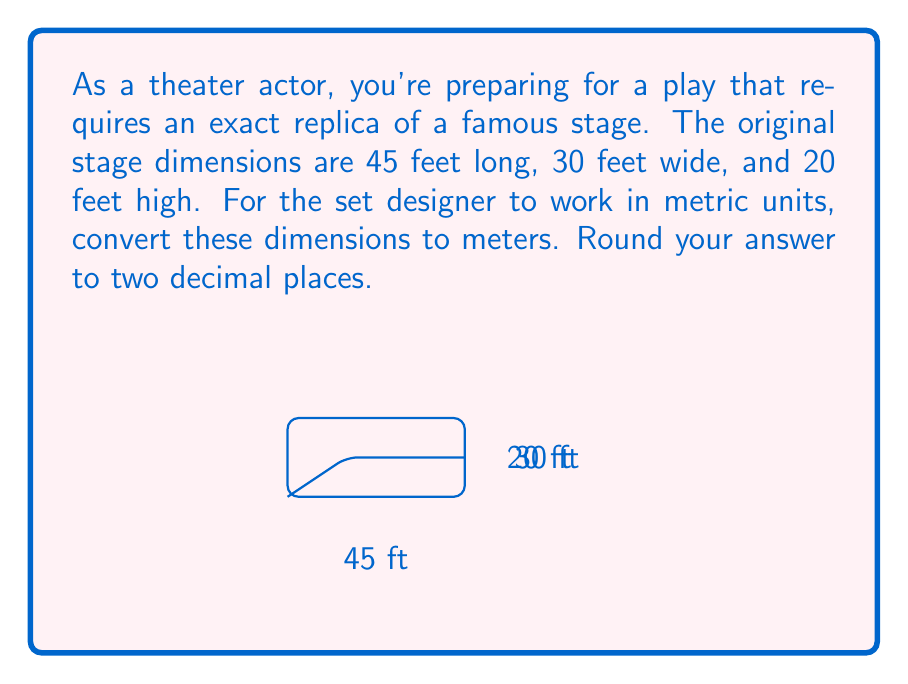Can you solve this math problem? To convert from feet to meters, we need to use the conversion factor:
1 foot = 0.3048 meters

Let's convert each dimension:

1. Length: 45 feet
   $45 \times 0.3048 = 13.716$ meters

2. Width: 30 feet
   $30 \times 0.3048 = 9.144$ meters

3. Height: 20 feet
   $20 \times 0.3048 = 6.096$ meters

Rounding each result to two decimal places:

Length: 13.72 meters
Width: 9.14 meters
Height: 6.10 meters
Answer: 13.72 m × 9.14 m × 6.10 m 